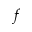<formula> <loc_0><loc_0><loc_500><loc_500>f</formula> 